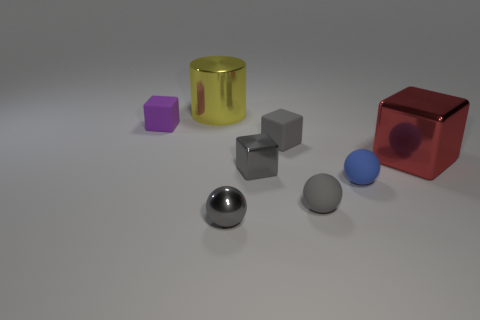Is the tiny shiny sphere the same color as the tiny shiny block?
Your response must be concise. Yes. What number of other metallic balls have the same color as the metal sphere?
Give a very brief answer. 0. What number of other objects are there of the same shape as the tiny blue matte object?
Keep it short and to the point. 2. Are there any large red blocks that have the same material as the yellow object?
Your answer should be compact. Yes. There is a purple cube that is the same size as the blue ball; what is its material?
Ensure brevity in your answer.  Rubber. The tiny sphere left of the tiny gray shiny object behind the small gray matte object that is in front of the blue matte sphere is what color?
Keep it short and to the point. Gray. There is a metallic thing that is behind the small purple thing; is it the same shape as the small metallic thing behind the blue thing?
Your answer should be compact. No. How many large red objects are there?
Offer a terse response. 1. What color is the metallic cube that is the same size as the blue thing?
Make the answer very short. Gray. Is the material of the large thing left of the big red object the same as the large red object in front of the yellow cylinder?
Your answer should be compact. Yes. 